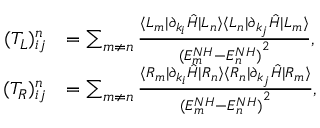Convert formula to latex. <formula><loc_0><loc_0><loc_500><loc_500>\begin{array} { r l } { ( T _ { L } ) _ { i j } ^ { n } } & { = \sum _ { m \neq n } \frac { \langle L _ { m } | \partial _ { k _ { i } } \hat { H } | L _ { n } \rangle \langle L _ { n } | \partial _ { k _ { j } } \hat { H } | L _ { m } \rangle } { { ( E _ { m } ^ { N H } - E _ { n } ^ { N H } ) } ^ { 2 } } , } \\ { ( T _ { R } ) _ { i j } ^ { n } } & { = \sum _ { m \neq n } \frac { \langle R _ { m } | \partial _ { k _ { i } } \hat { H } | R _ { n } \rangle \langle R _ { n } | \partial _ { k _ { j } } \hat { H } | R _ { m } \rangle } { { ( E _ { m } ^ { N H } - E _ { n } ^ { N H } ) } ^ { 2 } } , } \end{array}</formula> 